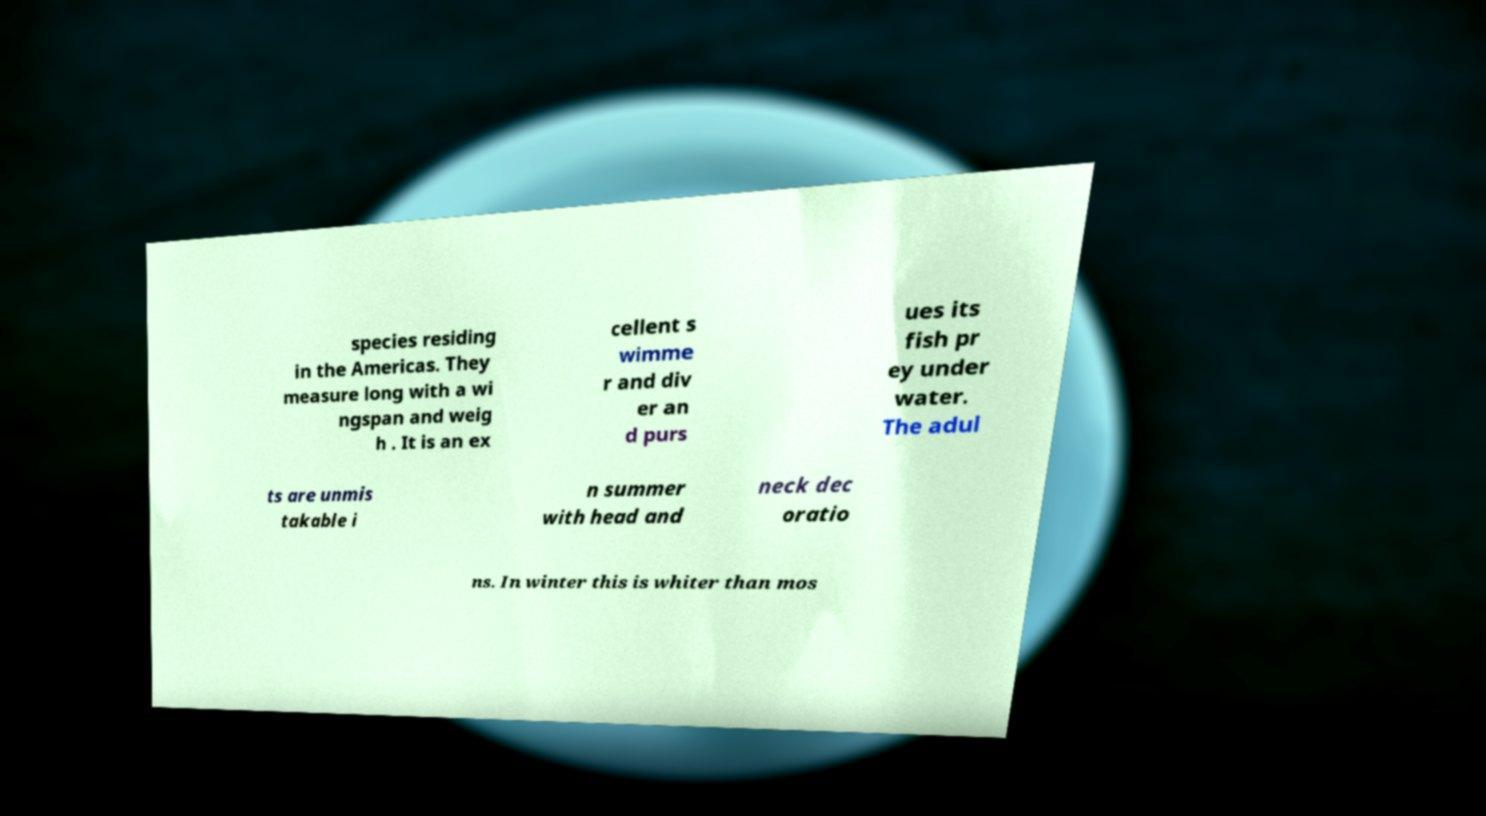What messages or text are displayed in this image? I need them in a readable, typed format. species residing in the Americas. They measure long with a wi ngspan and weig h . It is an ex cellent s wimme r and div er an d purs ues its fish pr ey under water. The adul ts are unmis takable i n summer with head and neck dec oratio ns. In winter this is whiter than mos 